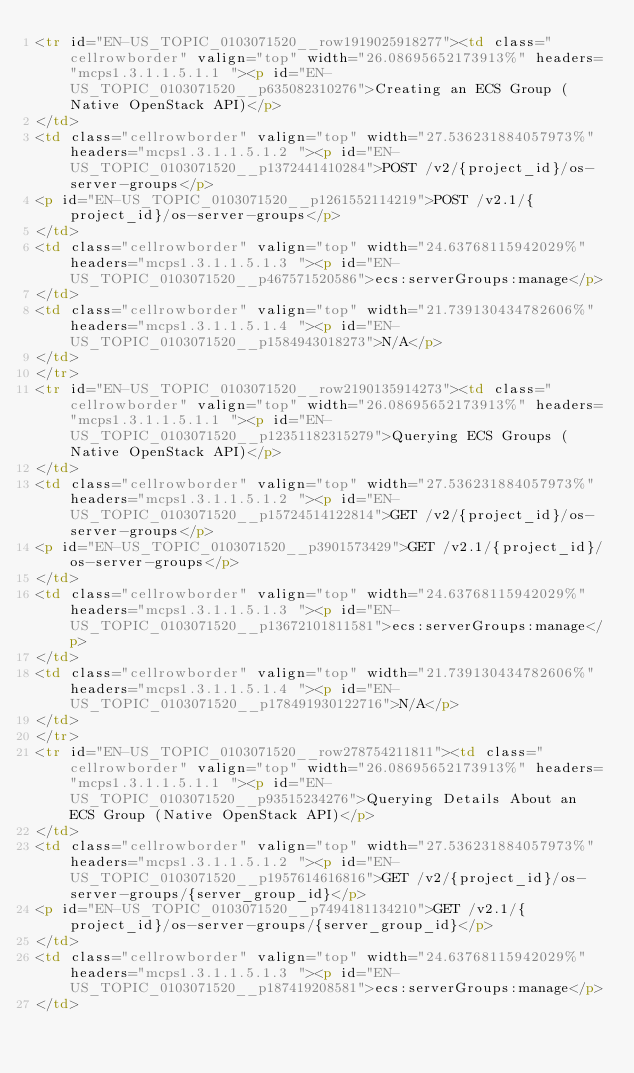Convert code to text. <code><loc_0><loc_0><loc_500><loc_500><_HTML_><tr id="EN-US_TOPIC_0103071520__row1919025918277"><td class="cellrowborder" valign="top" width="26.08695652173913%" headers="mcps1.3.1.1.5.1.1 "><p id="EN-US_TOPIC_0103071520__p635082310276">Creating an ECS Group (Native OpenStack API)</p>
</td>
<td class="cellrowborder" valign="top" width="27.536231884057973%" headers="mcps1.3.1.1.5.1.2 "><p id="EN-US_TOPIC_0103071520__p1372441410284">POST /v2/{project_id}/os-server-groups</p>
<p id="EN-US_TOPIC_0103071520__p1261552114219">POST /v2.1/{project_id}/os-server-groups</p>
</td>
<td class="cellrowborder" valign="top" width="24.63768115942029%" headers="mcps1.3.1.1.5.1.3 "><p id="EN-US_TOPIC_0103071520__p467571520586">ecs:serverGroups:manage</p>
</td>
<td class="cellrowborder" valign="top" width="21.739130434782606%" headers="mcps1.3.1.1.5.1.4 "><p id="EN-US_TOPIC_0103071520__p1584943018273">N/A</p>
</td>
</tr>
<tr id="EN-US_TOPIC_0103071520__row2190135914273"><td class="cellrowborder" valign="top" width="26.08695652173913%" headers="mcps1.3.1.1.5.1.1 "><p id="EN-US_TOPIC_0103071520__p12351182315279">Querying ECS Groups (Native OpenStack API)</p>
</td>
<td class="cellrowborder" valign="top" width="27.536231884057973%" headers="mcps1.3.1.1.5.1.2 "><p id="EN-US_TOPIC_0103071520__p15724514122814">GET /v2/{project_id}/os-server-groups</p>
<p id="EN-US_TOPIC_0103071520__p3901573429">GET /v2.1/{project_id}/os-server-groups</p>
</td>
<td class="cellrowborder" valign="top" width="24.63768115942029%" headers="mcps1.3.1.1.5.1.3 "><p id="EN-US_TOPIC_0103071520__p13672101811581">ecs:serverGroups:manage</p>
</td>
<td class="cellrowborder" valign="top" width="21.739130434782606%" headers="mcps1.3.1.1.5.1.4 "><p id="EN-US_TOPIC_0103071520__p178491930122716">N/A</p>
</td>
</tr>
<tr id="EN-US_TOPIC_0103071520__row278754211811"><td class="cellrowborder" valign="top" width="26.08695652173913%" headers="mcps1.3.1.1.5.1.1 "><p id="EN-US_TOPIC_0103071520__p93515234276">Querying Details About an ECS Group (Native OpenStack API)</p>
</td>
<td class="cellrowborder" valign="top" width="27.536231884057973%" headers="mcps1.3.1.1.5.1.2 "><p id="EN-US_TOPIC_0103071520__p1957614616816">GET /v2/{project_id}/os-server-groups/{server_group_id}</p>
<p id="EN-US_TOPIC_0103071520__p7494181134210">GET /v2.1/{project_id}/os-server-groups/{server_group_id}</p>
</td>
<td class="cellrowborder" valign="top" width="24.63768115942029%" headers="mcps1.3.1.1.5.1.3 "><p id="EN-US_TOPIC_0103071520__p187419208581">ecs:serverGroups:manage</p>
</td></code> 